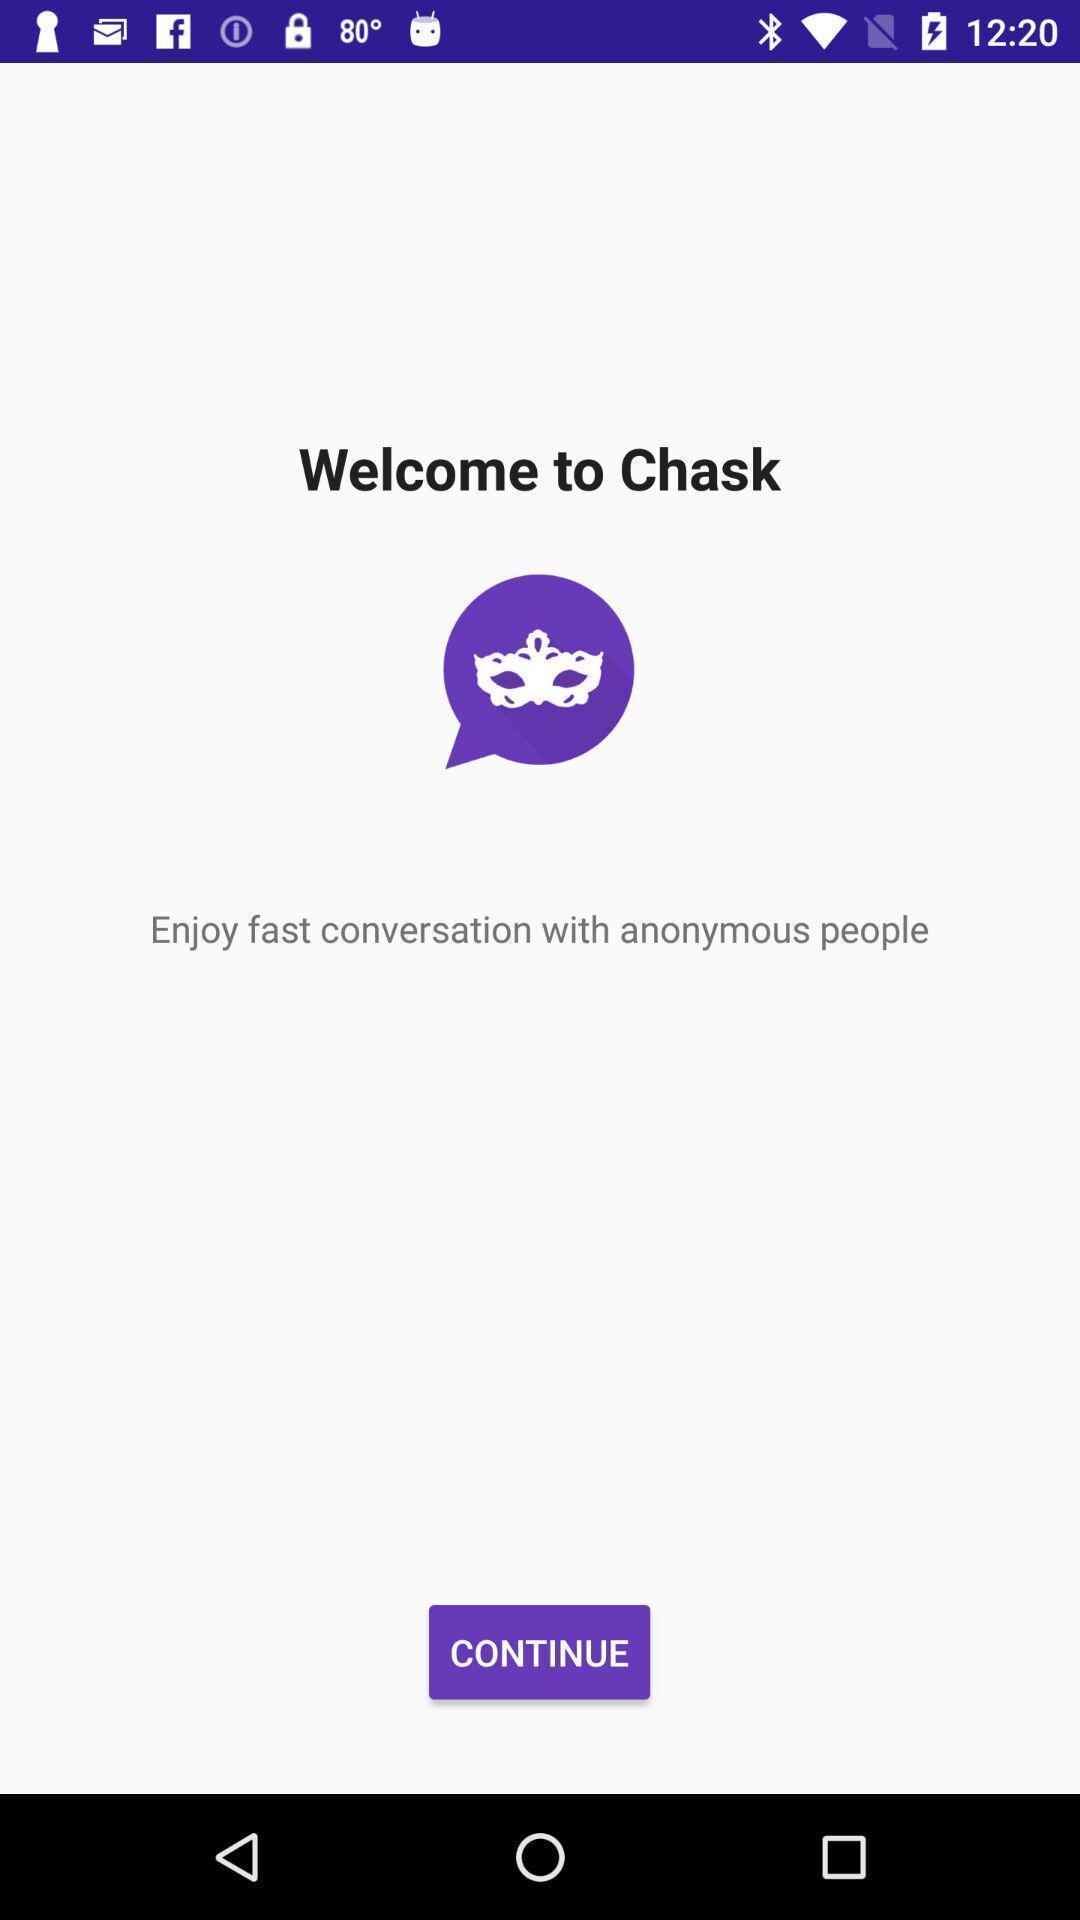Describe this image in words. Welcome page with options in a messaging app. 